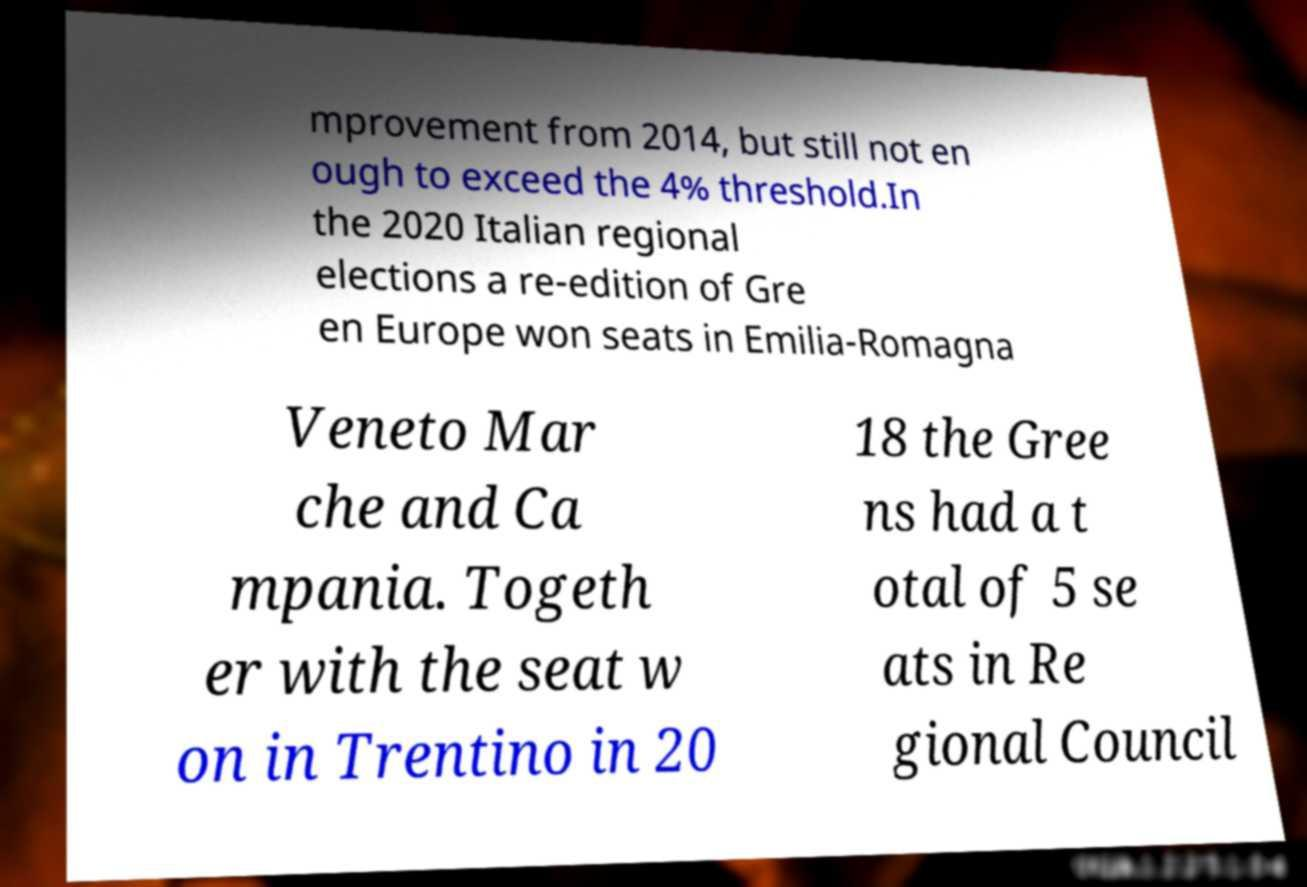For documentation purposes, I need the text within this image transcribed. Could you provide that? mprovement from 2014, but still not en ough to exceed the 4% threshold.In the 2020 Italian regional elections a re-edition of Gre en Europe won seats in Emilia-Romagna Veneto Mar che and Ca mpania. Togeth er with the seat w on in Trentino in 20 18 the Gree ns had a t otal of 5 se ats in Re gional Council 